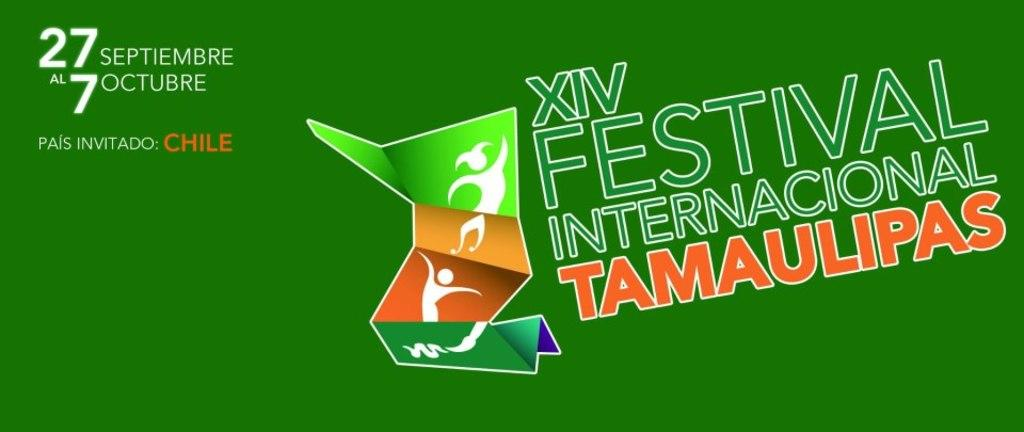<image>
Relay a brief, clear account of the picture shown. An international festival is designated as the XIV version of the event. 